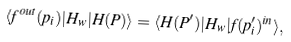Convert formula to latex. <formula><loc_0><loc_0><loc_500><loc_500>\langle f ^ { o u t } ( p _ { i } ) | H _ { w } | H ( P ) \rangle = \langle H ( P ^ { \prime } ) | H _ { w } | f ( p ^ { \prime } _ { i } ) ^ { i n } \rangle ,</formula> 